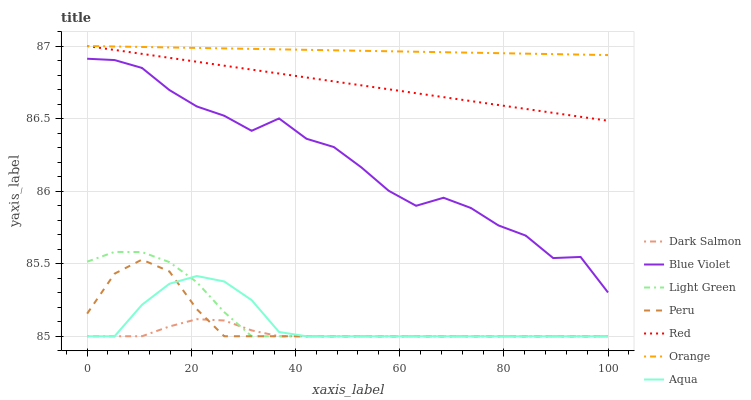Does Dark Salmon have the minimum area under the curve?
Answer yes or no. Yes. Does Orange have the maximum area under the curve?
Answer yes or no. Yes. Does Aqua have the minimum area under the curve?
Answer yes or no. No. Does Aqua have the maximum area under the curve?
Answer yes or no. No. Is Orange the smoothest?
Answer yes or no. Yes. Is Blue Violet the roughest?
Answer yes or no. Yes. Is Aqua the smoothest?
Answer yes or no. No. Is Aqua the roughest?
Answer yes or no. No. Does Light Green have the lowest value?
Answer yes or no. Yes. Does Blue Violet have the lowest value?
Answer yes or no. No. Does Red have the highest value?
Answer yes or no. Yes. Does Aqua have the highest value?
Answer yes or no. No. Is Peru less than Red?
Answer yes or no. Yes. Is Blue Violet greater than Light Green?
Answer yes or no. Yes. Does Aqua intersect Light Green?
Answer yes or no. Yes. Is Aqua less than Light Green?
Answer yes or no. No. Is Aqua greater than Light Green?
Answer yes or no. No. Does Peru intersect Red?
Answer yes or no. No. 